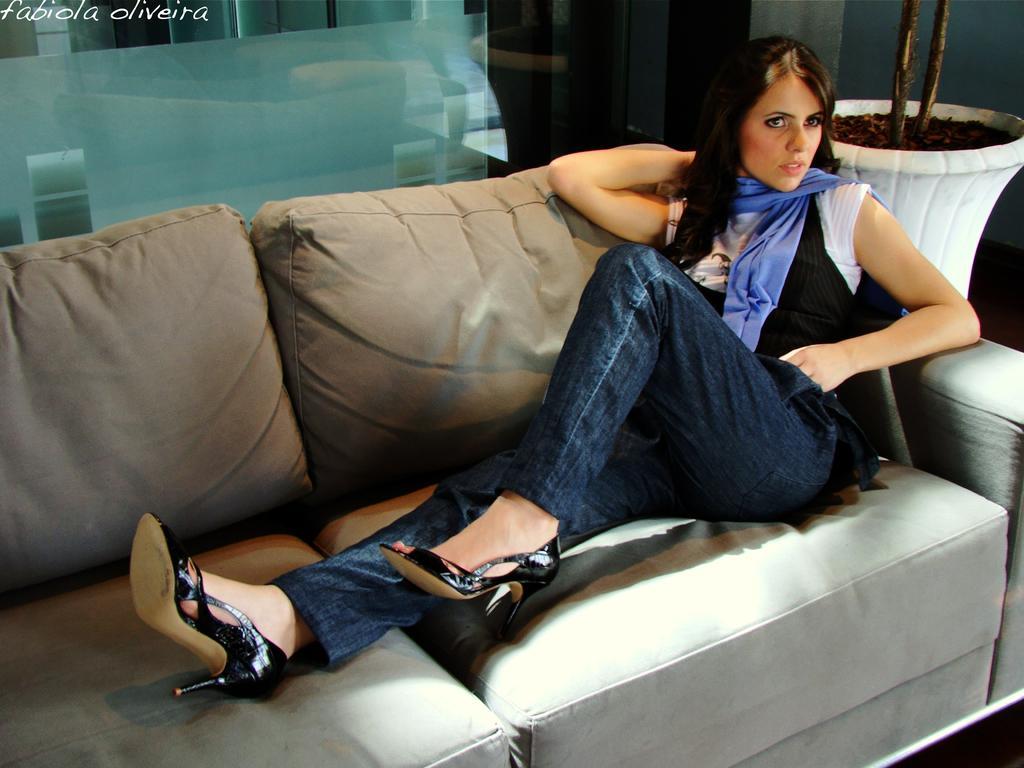How would you summarize this image in a sentence or two? This is the picture of a lady in black and white shirt, blue jeans and black footwear sitting on the sofa and decide the sofa that is a plant and behind her there is a glass wall. 